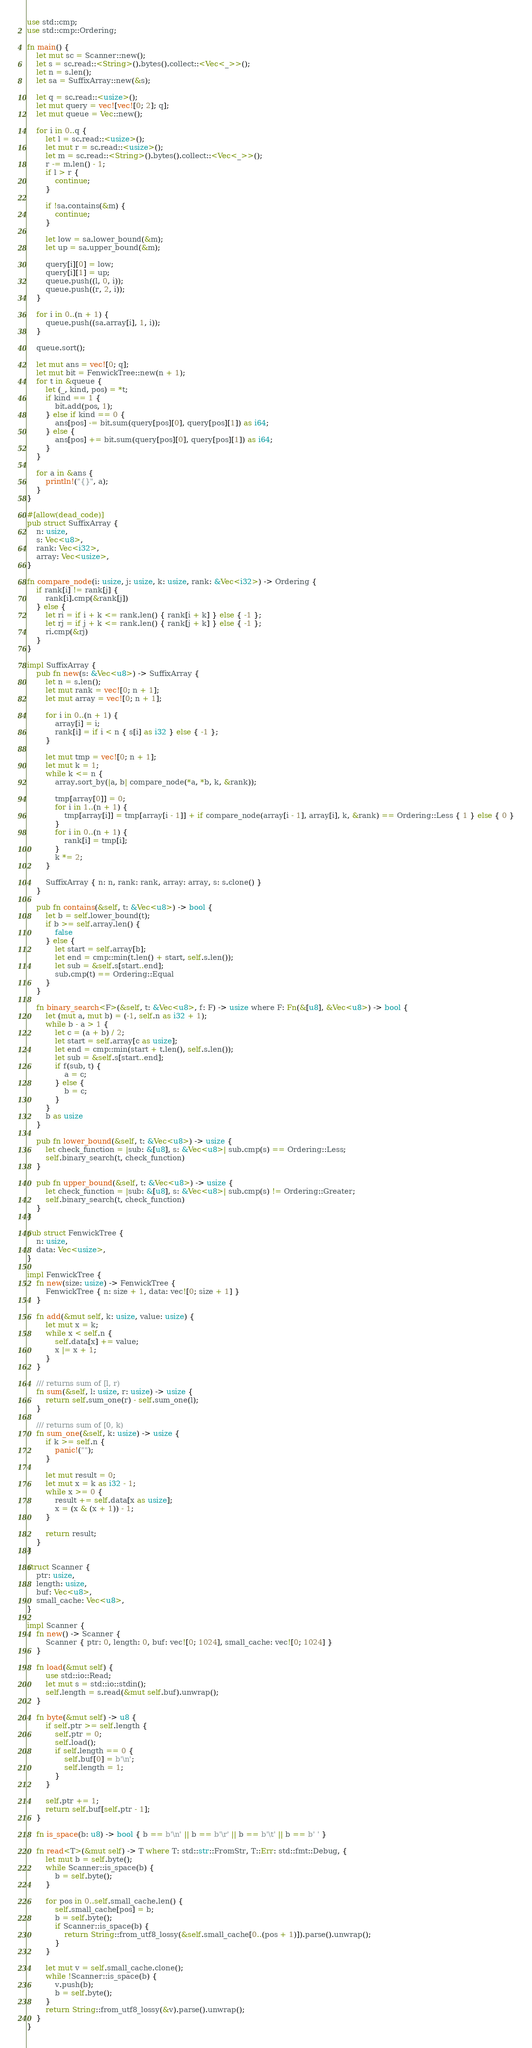<code> <loc_0><loc_0><loc_500><loc_500><_Rust_>use std::cmp;
use std::cmp::Ordering;

fn main() {
    let mut sc = Scanner::new();
    let s = sc.read::<String>().bytes().collect::<Vec<_>>();
    let n = s.len();
    let sa = SuffixArray::new(&s);

    let q = sc.read::<usize>();
    let mut query = vec![vec![0; 2]; q];
    let mut queue = Vec::new();

    for i in 0..q {
        let l = sc.read::<usize>();
        let mut r = sc.read::<usize>();
        let m = sc.read::<String>().bytes().collect::<Vec<_>>();
        r -= m.len() - 1;
        if l > r {
            continue;
        }

        if !sa.contains(&m) {
            continue;
        }

        let low = sa.lower_bound(&m);
        let up = sa.upper_bound(&m);

        query[i][0] = low;
        query[i][1] = up;
        queue.push((l, 0, i));
        queue.push((r, 2, i));
    }

    for i in 0..(n + 1) {
        queue.push((sa.array[i], 1, i));
    }

    queue.sort();

    let mut ans = vec![0; q];
    let mut bit = FenwickTree::new(n + 1);
    for t in &queue {
        let (_, kind, pos) = *t;
        if kind == 1 {
            bit.add(pos, 1);
        } else if kind == 0 {
            ans[pos] -= bit.sum(query[pos][0], query[pos][1]) as i64;
        } else {
            ans[pos] += bit.sum(query[pos][0], query[pos][1]) as i64;
        }
    }

    for a in &ans {
        println!("{}", a);
    }
}

#[allow(dead_code)]
pub struct SuffixArray {
    n: usize,
    s: Vec<u8>,
    rank: Vec<i32>,
    array: Vec<usize>,
}

fn compare_node(i: usize, j: usize, k: usize, rank: &Vec<i32>) -> Ordering {
    if rank[i] != rank[j] {
        rank[i].cmp(&rank[j])
    } else {
        let ri = if i + k <= rank.len() { rank[i + k] } else { -1 };
        let rj = if j + k <= rank.len() { rank[j + k] } else { -1 };
        ri.cmp(&rj)
    }
}

impl SuffixArray {
    pub fn new(s: &Vec<u8>) -> SuffixArray {
        let n = s.len();
        let mut rank = vec![0; n + 1];
        let mut array = vec![0; n + 1];

        for i in 0..(n + 1) {
            array[i] = i;
            rank[i] = if i < n { s[i] as i32 } else { -1 };
        }

        let mut tmp = vec![0; n + 1];
        let mut k = 1;
        while k <= n {
            array.sort_by(|a, b| compare_node(*a, *b, k, &rank));

            tmp[array[0]] = 0;
            for i in 1..(n + 1) {
                tmp[array[i]] = tmp[array[i - 1]] + if compare_node(array[i - 1], array[i], k, &rank) == Ordering::Less { 1 } else { 0 }
            }
            for i in 0..(n + 1) {
                rank[i] = tmp[i];
            }
            k *= 2;
        }

        SuffixArray { n: n, rank: rank, array: array, s: s.clone() }
    }

    pub fn contains(&self, t: &Vec<u8>) -> bool {
        let b = self.lower_bound(t);
        if b >= self.array.len() {
            false
        } else {
            let start = self.array[b];
            let end = cmp::min(t.len() + start, self.s.len());
            let sub = &self.s[start..end];
            sub.cmp(t) == Ordering::Equal
        }
    }

    fn binary_search<F>(&self, t: &Vec<u8>, f: F) -> usize where F: Fn(&[u8], &Vec<u8>) -> bool {
        let (mut a, mut b) = (-1, self.n as i32 + 1);
        while b - a > 1 {
            let c = (a + b) / 2;
            let start = self.array[c as usize];
            let end = cmp::min(start + t.len(), self.s.len());
            let sub = &self.s[start..end];
            if f(sub, t) {
                a = c;
            } else {
                b = c;
            }
        }
        b as usize
    }

    pub fn lower_bound(&self, t: &Vec<u8>) -> usize {
        let check_function = |sub: &[u8], s: &Vec<u8>| sub.cmp(s) == Ordering::Less;
        self.binary_search(t, check_function)
    }

    pub fn upper_bound(&self, t: &Vec<u8>) -> usize {
        let check_function = |sub: &[u8], s: &Vec<u8>| sub.cmp(s) != Ordering::Greater;
        self.binary_search(t, check_function)
    }
}

pub struct FenwickTree {
    n: usize,
    data: Vec<usize>,
}

impl FenwickTree {
    fn new(size: usize) -> FenwickTree {
        FenwickTree { n: size + 1, data: vec![0; size + 1] }
    }

    fn add(&mut self, k: usize, value: usize) {
        let mut x = k;
        while x < self.n {
            self.data[x] += value;
            x |= x + 1;
        }
    }

    /// returns sum of [l, r)
    fn sum(&self, l: usize, r: usize) -> usize {
        return self.sum_one(r) - self.sum_one(l);
    }

    /// returns sum of [0, k)
    fn sum_one(&self, k: usize) -> usize {
        if k >= self.n {
            panic!("");
        }

        let mut result = 0;
        let mut x = k as i32 - 1;
        while x >= 0 {
            result += self.data[x as usize];
            x = (x & (x + 1)) - 1;
        }

        return result;
    }
}

struct Scanner {
    ptr: usize,
    length: usize,
    buf: Vec<u8>,
    small_cache: Vec<u8>,
}

impl Scanner {
    fn new() -> Scanner {
        Scanner { ptr: 0, length: 0, buf: vec![0; 1024], small_cache: vec![0; 1024] }
    }

    fn load(&mut self) {
        use std::io::Read;
        let mut s = std::io::stdin();
        self.length = s.read(&mut self.buf).unwrap();
    }

    fn byte(&mut self) -> u8 {
        if self.ptr >= self.length {
            self.ptr = 0;
            self.load();
            if self.length == 0 {
                self.buf[0] = b'\n';
                self.length = 1;
            }
        }

        self.ptr += 1;
        return self.buf[self.ptr - 1];
    }

    fn is_space(b: u8) -> bool { b == b'\n' || b == b'\r' || b == b'\t' || b == b' ' }

    fn read<T>(&mut self) -> T where T: std::str::FromStr, T::Err: std::fmt::Debug, {
        let mut b = self.byte();
        while Scanner::is_space(b) {
            b = self.byte();
        }

        for pos in 0..self.small_cache.len() {
            self.small_cache[pos] = b;
            b = self.byte();
            if Scanner::is_space(b) {
                return String::from_utf8_lossy(&self.small_cache[0..(pos + 1)]).parse().unwrap();
            }
        }

        let mut v = self.small_cache.clone();
        while !Scanner::is_space(b) {
            v.push(b);
            b = self.byte();
        }
        return String::from_utf8_lossy(&v).parse().unwrap();
    }
}


</code> 